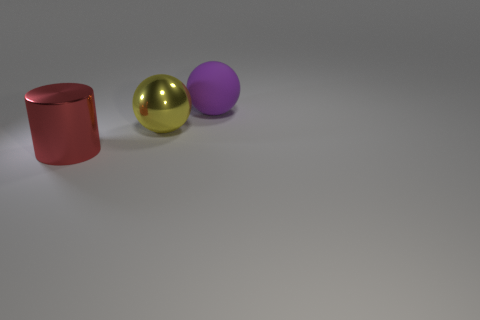How many large things are behind the object in front of the ball that is in front of the large purple rubber ball?
Give a very brief answer. 2. What number of objects are in front of the big purple rubber ball and behind the big red metal cylinder?
Provide a short and direct response. 1. Are there any other things that are the same color as the large matte ball?
Provide a short and direct response. No. How many rubber objects are tiny red spheres or red cylinders?
Your answer should be compact. 0. What material is the sphere that is to the right of the metal thing behind the thing on the left side of the big yellow thing made of?
Provide a succinct answer. Rubber. There is a cylinder in front of the shiny thing behind the large red metallic thing; what is it made of?
Make the answer very short. Metal. Does the red shiny thing that is to the left of the large yellow object have the same size as the sphere that is left of the purple rubber ball?
Give a very brief answer. Yes. Are there any other things that are made of the same material as the big yellow sphere?
Offer a very short reply. Yes. What number of small things are either green rubber blocks or purple matte things?
Give a very brief answer. 0. How many things are metal things that are on the right side of the red cylinder or small brown metallic cubes?
Keep it short and to the point. 1. 